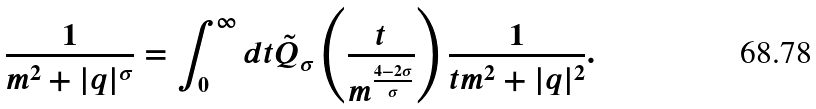<formula> <loc_0><loc_0><loc_500><loc_500>\frac { 1 } { m ^ { 2 } + | q | ^ { \sigma } } = \int _ { 0 } ^ { \infty } d t { \tilde { Q } } _ { \sigma } \left ( \frac { t } { m ^ { \frac { 4 - 2 \sigma } { \sigma } } } \right ) \frac { 1 } { t m ^ { 2 } + | q | ^ { 2 } } .</formula> 